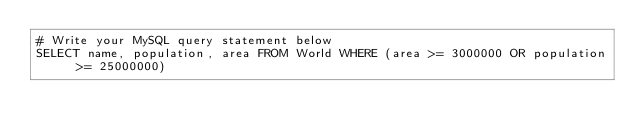<code> <loc_0><loc_0><loc_500><loc_500><_SQL_># Write your MySQL query statement below
SELECT name, population, area FROM World WHERE (area >= 3000000 OR population >= 25000000)</code> 